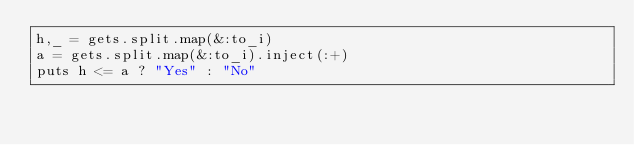<code> <loc_0><loc_0><loc_500><loc_500><_Ruby_>h,_ = gets.split.map(&:to_i)
a = gets.split.map(&:to_i).inject(:+)
puts h <= a ? "Yes" : "No"</code> 